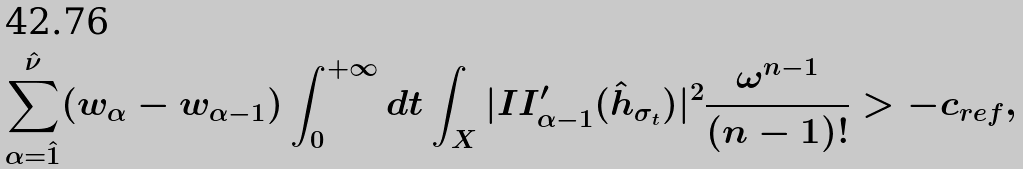Convert formula to latex. <formula><loc_0><loc_0><loc_500><loc_500>\sum _ { \alpha = \hat { 1 } } ^ { \hat { \nu } } ( w _ { \alpha } - w _ { \alpha - 1 } ) \int _ { 0 } ^ { + \infty } d t \int _ { X } | I I _ { \alpha - 1 } ^ { \prime } ( \hat { h } _ { \sigma _ { t } } ) | ^ { 2 } \frac { \omega ^ { n - 1 } } { ( n - 1 ) ! } > - c _ { r e f } ,</formula> 